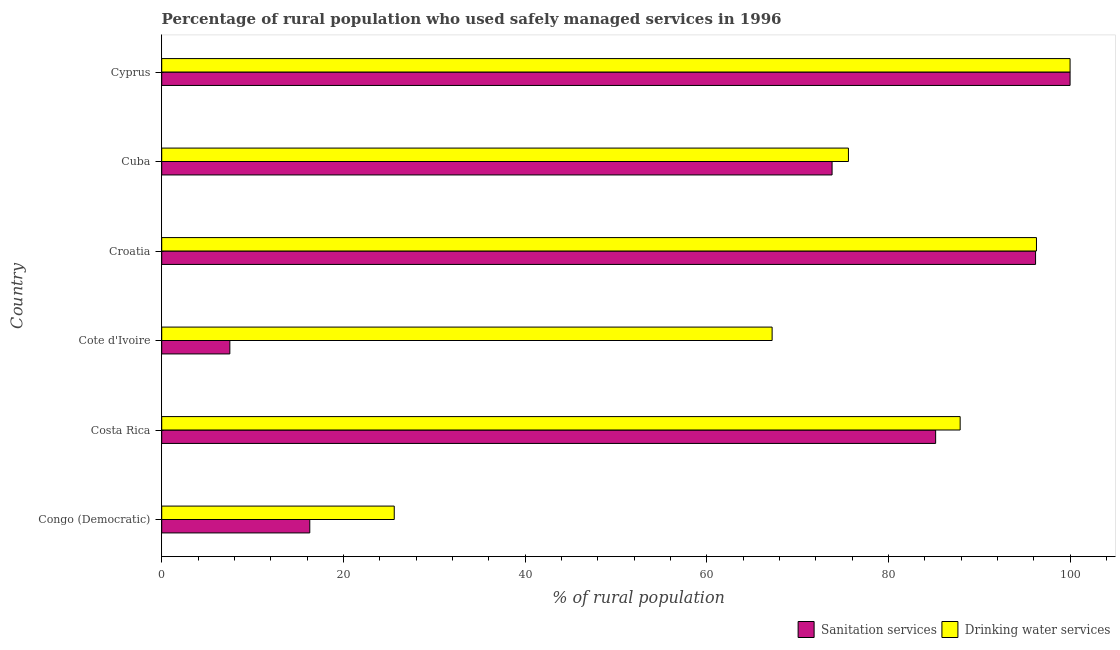Are the number of bars per tick equal to the number of legend labels?
Keep it short and to the point. Yes. How many bars are there on the 6th tick from the top?
Offer a very short reply. 2. How many bars are there on the 4th tick from the bottom?
Keep it short and to the point. 2. What is the label of the 6th group of bars from the top?
Make the answer very short. Congo (Democratic). In how many cases, is the number of bars for a given country not equal to the number of legend labels?
Offer a terse response. 0. What is the percentage of rural population who used sanitation services in Cuba?
Your answer should be very brief. 73.8. Across all countries, what is the minimum percentage of rural population who used drinking water services?
Give a very brief answer. 25.6. In which country was the percentage of rural population who used drinking water services maximum?
Offer a very short reply. Cyprus. In which country was the percentage of rural population who used sanitation services minimum?
Keep it short and to the point. Cote d'Ivoire. What is the total percentage of rural population who used drinking water services in the graph?
Ensure brevity in your answer.  452.6. What is the difference between the percentage of rural population who used drinking water services in Congo (Democratic) and that in Croatia?
Offer a terse response. -70.7. What is the difference between the percentage of rural population who used sanitation services in Costa Rica and the percentage of rural population who used drinking water services in Congo (Democratic)?
Make the answer very short. 59.6. What is the average percentage of rural population who used sanitation services per country?
Provide a short and direct response. 63.17. What is the difference between the percentage of rural population who used drinking water services and percentage of rural population who used sanitation services in Congo (Democratic)?
Offer a very short reply. 9.3. In how many countries, is the percentage of rural population who used sanitation services greater than 52 %?
Give a very brief answer. 4. What is the ratio of the percentage of rural population who used sanitation services in Costa Rica to that in Cote d'Ivoire?
Provide a short and direct response. 11.36. Is the percentage of rural population who used drinking water services in Croatia less than that in Cuba?
Give a very brief answer. No. Is the difference between the percentage of rural population who used drinking water services in Croatia and Cuba greater than the difference between the percentage of rural population who used sanitation services in Croatia and Cuba?
Offer a terse response. No. What is the difference between the highest and the second highest percentage of rural population who used sanitation services?
Keep it short and to the point. 3.8. What is the difference between the highest and the lowest percentage of rural population who used drinking water services?
Your response must be concise. 74.4. In how many countries, is the percentage of rural population who used drinking water services greater than the average percentage of rural population who used drinking water services taken over all countries?
Your answer should be very brief. 4. What does the 2nd bar from the top in Congo (Democratic) represents?
Your answer should be compact. Sanitation services. What does the 2nd bar from the bottom in Cuba represents?
Your response must be concise. Drinking water services. How many bars are there?
Give a very brief answer. 12. Where does the legend appear in the graph?
Your answer should be compact. Bottom right. How many legend labels are there?
Provide a short and direct response. 2. What is the title of the graph?
Make the answer very short. Percentage of rural population who used safely managed services in 1996. Does "Techinal cooperation" appear as one of the legend labels in the graph?
Your response must be concise. No. What is the label or title of the X-axis?
Your answer should be compact. % of rural population. What is the label or title of the Y-axis?
Give a very brief answer. Country. What is the % of rural population of Drinking water services in Congo (Democratic)?
Your answer should be compact. 25.6. What is the % of rural population of Sanitation services in Costa Rica?
Your answer should be very brief. 85.2. What is the % of rural population of Drinking water services in Costa Rica?
Provide a short and direct response. 87.9. What is the % of rural population of Sanitation services in Cote d'Ivoire?
Make the answer very short. 7.5. What is the % of rural population of Drinking water services in Cote d'Ivoire?
Provide a short and direct response. 67.2. What is the % of rural population in Sanitation services in Croatia?
Keep it short and to the point. 96.2. What is the % of rural population in Drinking water services in Croatia?
Offer a very short reply. 96.3. What is the % of rural population in Sanitation services in Cuba?
Your answer should be very brief. 73.8. What is the % of rural population in Drinking water services in Cuba?
Make the answer very short. 75.6. What is the % of rural population in Sanitation services in Cyprus?
Give a very brief answer. 100. What is the % of rural population in Drinking water services in Cyprus?
Give a very brief answer. 100. Across all countries, what is the maximum % of rural population in Sanitation services?
Provide a short and direct response. 100. Across all countries, what is the minimum % of rural population of Sanitation services?
Ensure brevity in your answer.  7.5. Across all countries, what is the minimum % of rural population of Drinking water services?
Offer a very short reply. 25.6. What is the total % of rural population of Sanitation services in the graph?
Your answer should be compact. 379. What is the total % of rural population of Drinking water services in the graph?
Keep it short and to the point. 452.6. What is the difference between the % of rural population in Sanitation services in Congo (Democratic) and that in Costa Rica?
Offer a terse response. -68.9. What is the difference between the % of rural population in Drinking water services in Congo (Democratic) and that in Costa Rica?
Offer a terse response. -62.3. What is the difference between the % of rural population of Drinking water services in Congo (Democratic) and that in Cote d'Ivoire?
Provide a succinct answer. -41.6. What is the difference between the % of rural population of Sanitation services in Congo (Democratic) and that in Croatia?
Ensure brevity in your answer.  -79.9. What is the difference between the % of rural population of Drinking water services in Congo (Democratic) and that in Croatia?
Give a very brief answer. -70.7. What is the difference between the % of rural population of Sanitation services in Congo (Democratic) and that in Cuba?
Provide a succinct answer. -57.5. What is the difference between the % of rural population of Sanitation services in Congo (Democratic) and that in Cyprus?
Ensure brevity in your answer.  -83.7. What is the difference between the % of rural population in Drinking water services in Congo (Democratic) and that in Cyprus?
Make the answer very short. -74.4. What is the difference between the % of rural population in Sanitation services in Costa Rica and that in Cote d'Ivoire?
Make the answer very short. 77.7. What is the difference between the % of rural population in Drinking water services in Costa Rica and that in Cote d'Ivoire?
Offer a very short reply. 20.7. What is the difference between the % of rural population in Drinking water services in Costa Rica and that in Cuba?
Provide a succinct answer. 12.3. What is the difference between the % of rural population of Sanitation services in Costa Rica and that in Cyprus?
Provide a short and direct response. -14.8. What is the difference between the % of rural population in Sanitation services in Cote d'Ivoire and that in Croatia?
Provide a succinct answer. -88.7. What is the difference between the % of rural population of Drinking water services in Cote d'Ivoire and that in Croatia?
Keep it short and to the point. -29.1. What is the difference between the % of rural population in Sanitation services in Cote d'Ivoire and that in Cuba?
Your answer should be compact. -66.3. What is the difference between the % of rural population of Sanitation services in Cote d'Ivoire and that in Cyprus?
Keep it short and to the point. -92.5. What is the difference between the % of rural population of Drinking water services in Cote d'Ivoire and that in Cyprus?
Provide a succinct answer. -32.8. What is the difference between the % of rural population in Sanitation services in Croatia and that in Cuba?
Your answer should be compact. 22.4. What is the difference between the % of rural population in Drinking water services in Croatia and that in Cuba?
Your answer should be very brief. 20.7. What is the difference between the % of rural population of Drinking water services in Croatia and that in Cyprus?
Your answer should be very brief. -3.7. What is the difference between the % of rural population in Sanitation services in Cuba and that in Cyprus?
Offer a very short reply. -26.2. What is the difference between the % of rural population of Drinking water services in Cuba and that in Cyprus?
Offer a terse response. -24.4. What is the difference between the % of rural population in Sanitation services in Congo (Democratic) and the % of rural population in Drinking water services in Costa Rica?
Provide a succinct answer. -71.6. What is the difference between the % of rural population in Sanitation services in Congo (Democratic) and the % of rural population in Drinking water services in Cote d'Ivoire?
Offer a terse response. -50.9. What is the difference between the % of rural population of Sanitation services in Congo (Democratic) and the % of rural population of Drinking water services in Croatia?
Your answer should be very brief. -80. What is the difference between the % of rural population of Sanitation services in Congo (Democratic) and the % of rural population of Drinking water services in Cuba?
Your response must be concise. -59.3. What is the difference between the % of rural population in Sanitation services in Congo (Democratic) and the % of rural population in Drinking water services in Cyprus?
Offer a terse response. -83.7. What is the difference between the % of rural population in Sanitation services in Costa Rica and the % of rural population in Drinking water services in Cote d'Ivoire?
Offer a very short reply. 18. What is the difference between the % of rural population in Sanitation services in Costa Rica and the % of rural population in Drinking water services in Cuba?
Provide a short and direct response. 9.6. What is the difference between the % of rural population in Sanitation services in Costa Rica and the % of rural population in Drinking water services in Cyprus?
Offer a very short reply. -14.8. What is the difference between the % of rural population in Sanitation services in Cote d'Ivoire and the % of rural population in Drinking water services in Croatia?
Offer a terse response. -88.8. What is the difference between the % of rural population in Sanitation services in Cote d'Ivoire and the % of rural population in Drinking water services in Cuba?
Your answer should be compact. -68.1. What is the difference between the % of rural population of Sanitation services in Cote d'Ivoire and the % of rural population of Drinking water services in Cyprus?
Offer a terse response. -92.5. What is the difference between the % of rural population of Sanitation services in Croatia and the % of rural population of Drinking water services in Cuba?
Give a very brief answer. 20.6. What is the difference between the % of rural population in Sanitation services in Croatia and the % of rural population in Drinking water services in Cyprus?
Provide a succinct answer. -3.8. What is the difference between the % of rural population of Sanitation services in Cuba and the % of rural population of Drinking water services in Cyprus?
Make the answer very short. -26.2. What is the average % of rural population of Sanitation services per country?
Make the answer very short. 63.17. What is the average % of rural population in Drinking water services per country?
Offer a terse response. 75.43. What is the difference between the % of rural population in Sanitation services and % of rural population in Drinking water services in Cote d'Ivoire?
Keep it short and to the point. -59.7. What is the difference between the % of rural population of Sanitation services and % of rural population of Drinking water services in Croatia?
Give a very brief answer. -0.1. What is the difference between the % of rural population in Sanitation services and % of rural population in Drinking water services in Cyprus?
Your answer should be compact. 0. What is the ratio of the % of rural population of Sanitation services in Congo (Democratic) to that in Costa Rica?
Ensure brevity in your answer.  0.19. What is the ratio of the % of rural population of Drinking water services in Congo (Democratic) to that in Costa Rica?
Your response must be concise. 0.29. What is the ratio of the % of rural population of Sanitation services in Congo (Democratic) to that in Cote d'Ivoire?
Give a very brief answer. 2.17. What is the ratio of the % of rural population in Drinking water services in Congo (Democratic) to that in Cote d'Ivoire?
Your answer should be very brief. 0.38. What is the ratio of the % of rural population of Sanitation services in Congo (Democratic) to that in Croatia?
Offer a terse response. 0.17. What is the ratio of the % of rural population of Drinking water services in Congo (Democratic) to that in Croatia?
Your response must be concise. 0.27. What is the ratio of the % of rural population in Sanitation services in Congo (Democratic) to that in Cuba?
Offer a very short reply. 0.22. What is the ratio of the % of rural population in Drinking water services in Congo (Democratic) to that in Cuba?
Ensure brevity in your answer.  0.34. What is the ratio of the % of rural population of Sanitation services in Congo (Democratic) to that in Cyprus?
Provide a succinct answer. 0.16. What is the ratio of the % of rural population in Drinking water services in Congo (Democratic) to that in Cyprus?
Provide a short and direct response. 0.26. What is the ratio of the % of rural population of Sanitation services in Costa Rica to that in Cote d'Ivoire?
Your answer should be very brief. 11.36. What is the ratio of the % of rural population in Drinking water services in Costa Rica to that in Cote d'Ivoire?
Make the answer very short. 1.31. What is the ratio of the % of rural population of Sanitation services in Costa Rica to that in Croatia?
Your answer should be compact. 0.89. What is the ratio of the % of rural population of Drinking water services in Costa Rica to that in Croatia?
Give a very brief answer. 0.91. What is the ratio of the % of rural population in Sanitation services in Costa Rica to that in Cuba?
Provide a succinct answer. 1.15. What is the ratio of the % of rural population of Drinking water services in Costa Rica to that in Cuba?
Offer a very short reply. 1.16. What is the ratio of the % of rural population of Sanitation services in Costa Rica to that in Cyprus?
Your answer should be very brief. 0.85. What is the ratio of the % of rural population in Drinking water services in Costa Rica to that in Cyprus?
Give a very brief answer. 0.88. What is the ratio of the % of rural population in Sanitation services in Cote d'Ivoire to that in Croatia?
Offer a very short reply. 0.08. What is the ratio of the % of rural population of Drinking water services in Cote d'Ivoire to that in Croatia?
Your answer should be compact. 0.7. What is the ratio of the % of rural population of Sanitation services in Cote d'Ivoire to that in Cuba?
Offer a very short reply. 0.1. What is the ratio of the % of rural population of Drinking water services in Cote d'Ivoire to that in Cuba?
Provide a succinct answer. 0.89. What is the ratio of the % of rural population of Sanitation services in Cote d'Ivoire to that in Cyprus?
Your response must be concise. 0.07. What is the ratio of the % of rural population in Drinking water services in Cote d'Ivoire to that in Cyprus?
Your answer should be compact. 0.67. What is the ratio of the % of rural population of Sanitation services in Croatia to that in Cuba?
Offer a very short reply. 1.3. What is the ratio of the % of rural population in Drinking water services in Croatia to that in Cuba?
Offer a very short reply. 1.27. What is the ratio of the % of rural population in Sanitation services in Cuba to that in Cyprus?
Provide a short and direct response. 0.74. What is the ratio of the % of rural population in Drinking water services in Cuba to that in Cyprus?
Your response must be concise. 0.76. What is the difference between the highest and the lowest % of rural population in Sanitation services?
Your answer should be very brief. 92.5. What is the difference between the highest and the lowest % of rural population in Drinking water services?
Your answer should be compact. 74.4. 